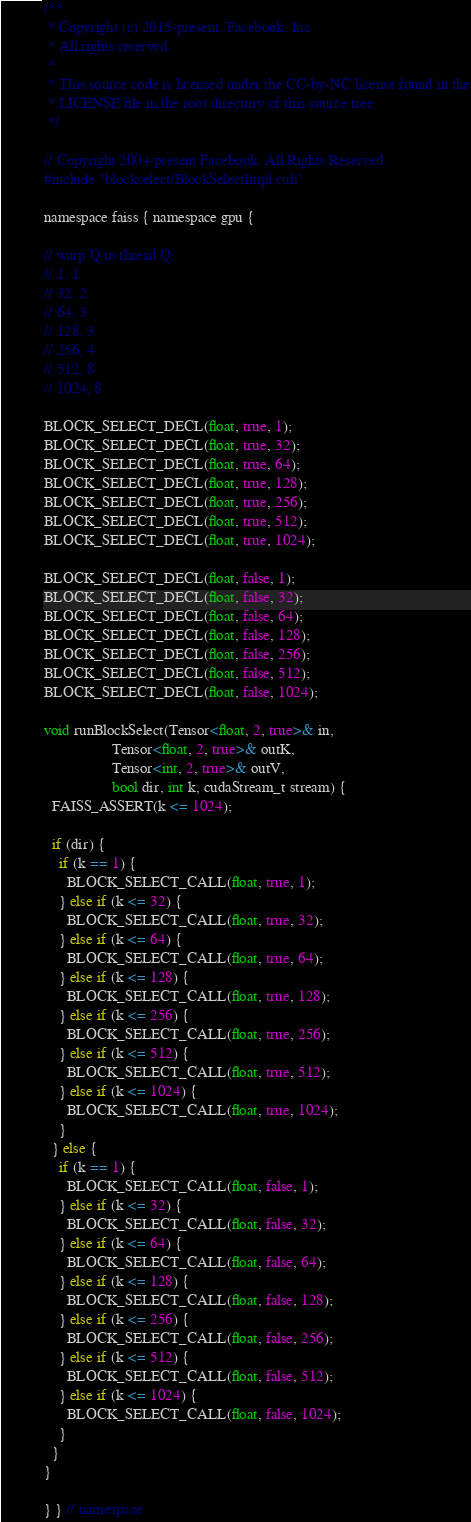Convert code to text. <code><loc_0><loc_0><loc_500><loc_500><_Cuda_>
/**
 * Copyright (c) 2015-present, Facebook, Inc.
 * All rights reserved.
 *
 * This source code is licensed under the CC-by-NC license found in the
 * LICENSE file in the root directory of this source tree.
 */

// Copyright 2004-present Facebook. All Rights Reserved.
#include "blockselect/BlockSelectImpl.cuh"

namespace faiss { namespace gpu {

// warp Q to thread Q:
// 1, 1
// 32, 2
// 64, 3
// 128, 3
// 256, 4
// 512, 8
// 1024, 8

BLOCK_SELECT_DECL(float, true, 1);
BLOCK_SELECT_DECL(float, true, 32);
BLOCK_SELECT_DECL(float, true, 64);
BLOCK_SELECT_DECL(float, true, 128);
BLOCK_SELECT_DECL(float, true, 256);
BLOCK_SELECT_DECL(float, true, 512);
BLOCK_SELECT_DECL(float, true, 1024);

BLOCK_SELECT_DECL(float, false, 1);
BLOCK_SELECT_DECL(float, false, 32);
BLOCK_SELECT_DECL(float, false, 64);
BLOCK_SELECT_DECL(float, false, 128);
BLOCK_SELECT_DECL(float, false, 256);
BLOCK_SELECT_DECL(float, false, 512);
BLOCK_SELECT_DECL(float, false, 1024);

void runBlockSelect(Tensor<float, 2, true>& in,
                  Tensor<float, 2, true>& outK,
                  Tensor<int, 2, true>& outV,
                  bool dir, int k, cudaStream_t stream) {
  FAISS_ASSERT(k <= 1024);

  if (dir) {
    if (k == 1) {
      BLOCK_SELECT_CALL(float, true, 1);
    } else if (k <= 32) {
      BLOCK_SELECT_CALL(float, true, 32);
    } else if (k <= 64) {
      BLOCK_SELECT_CALL(float, true, 64);
    } else if (k <= 128) {
      BLOCK_SELECT_CALL(float, true, 128);
    } else if (k <= 256) {
      BLOCK_SELECT_CALL(float, true, 256);
    } else if (k <= 512) {
      BLOCK_SELECT_CALL(float, true, 512);
    } else if (k <= 1024) {
      BLOCK_SELECT_CALL(float, true, 1024);
    }
  } else {
    if (k == 1) {
      BLOCK_SELECT_CALL(float, false, 1);
    } else if (k <= 32) {
      BLOCK_SELECT_CALL(float, false, 32);
    } else if (k <= 64) {
      BLOCK_SELECT_CALL(float, false, 64);
    } else if (k <= 128) {
      BLOCK_SELECT_CALL(float, false, 128);
    } else if (k <= 256) {
      BLOCK_SELECT_CALL(float, false, 256);
    } else if (k <= 512) {
      BLOCK_SELECT_CALL(float, false, 512);
    } else if (k <= 1024) {
      BLOCK_SELECT_CALL(float, false, 1024);
    }
  }
}

} } // namespace
</code> 